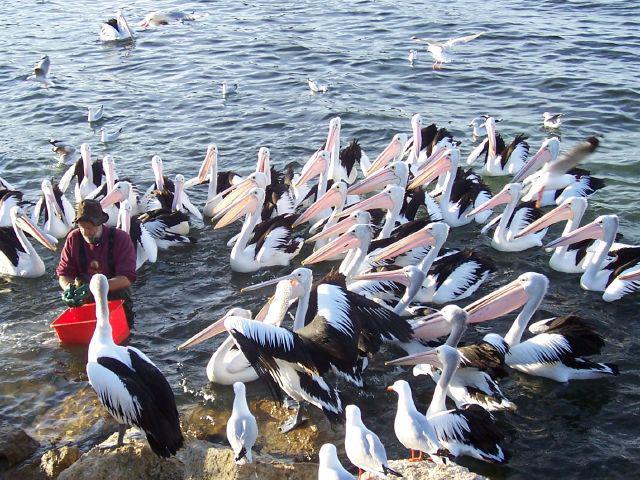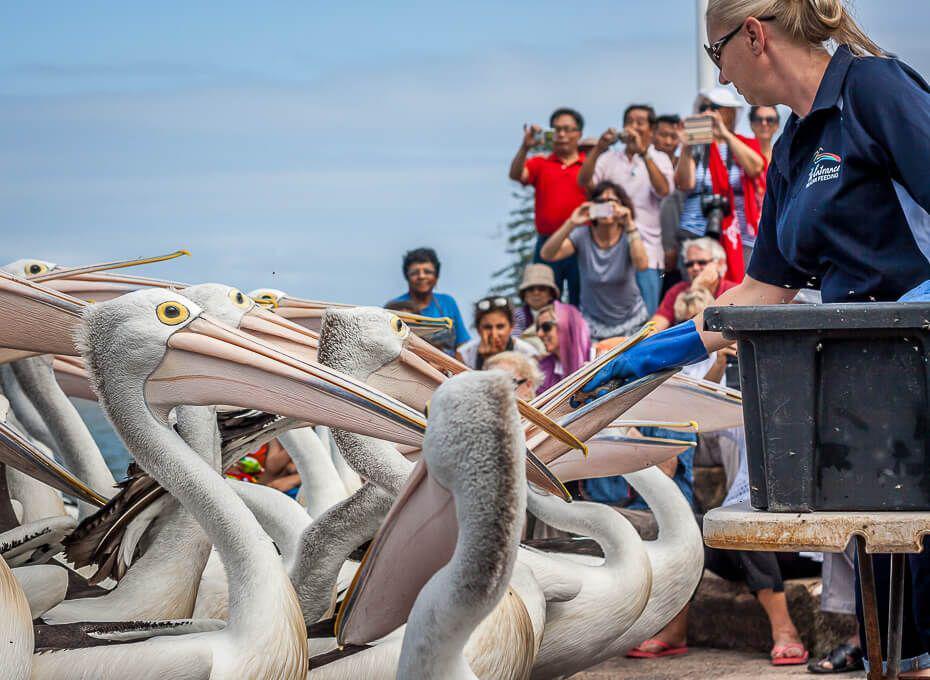The first image is the image on the left, the second image is the image on the right. Considering the images on both sides, is "There is a red bucket surrounded by many pelicans." valid? Answer yes or no. Yes. The first image is the image on the left, the second image is the image on the right. For the images shown, is this caption "There is a man wearing a blue jacket in the center of the image." true? Answer yes or no. No. 